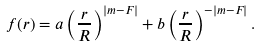Convert formula to latex. <formula><loc_0><loc_0><loc_500><loc_500>f ( r ) = a \left ( \frac { r } { R } \right ) ^ { | m - F | } + b \left ( \frac { r } { R } \right ) ^ { - | m - F | } .</formula> 